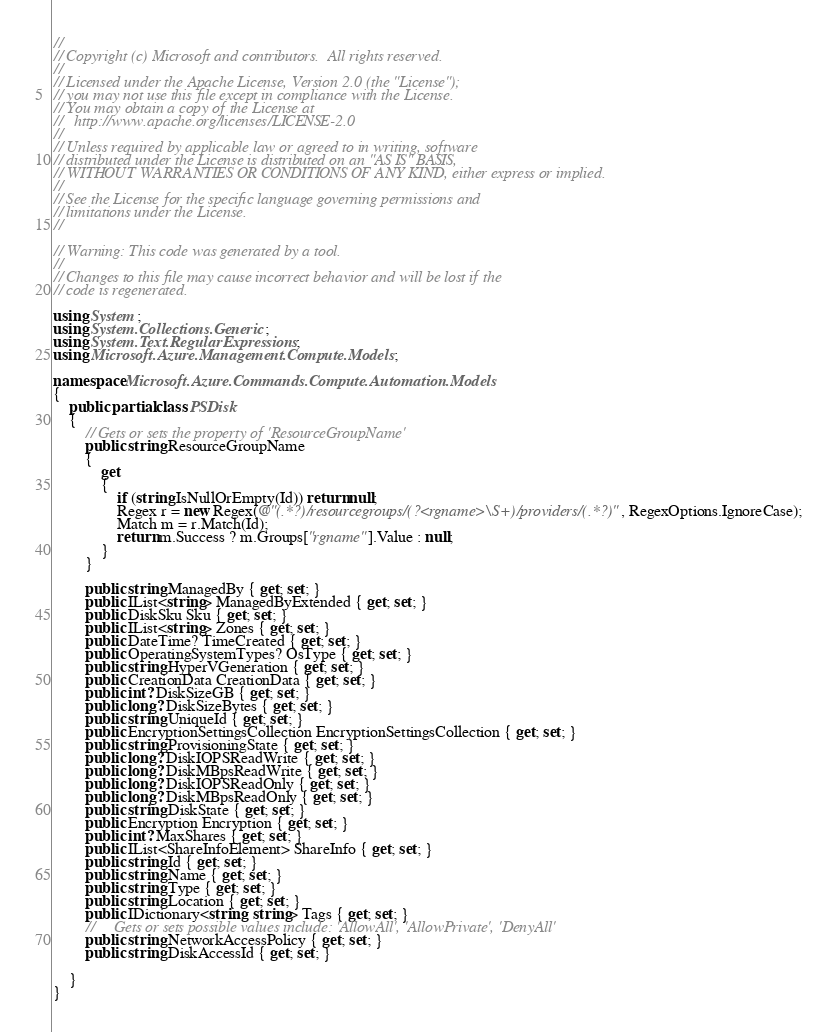<code> <loc_0><loc_0><loc_500><loc_500><_C#_>//
// Copyright (c) Microsoft and contributors.  All rights reserved.
//
// Licensed under the Apache License, Version 2.0 (the "License");
// you may not use this file except in compliance with the License.
// You may obtain a copy of the License at
//   http://www.apache.org/licenses/LICENSE-2.0
//
// Unless required by applicable law or agreed to in writing, software
// distributed under the License is distributed on an "AS IS" BASIS,
// WITHOUT WARRANTIES OR CONDITIONS OF ANY KIND, either express or implied.
//
// See the License for the specific language governing permissions and
// limitations under the License.
//

// Warning: This code was generated by a tool.
//
// Changes to this file may cause incorrect behavior and will be lost if the
// code is regenerated.

using System;
using System.Collections.Generic;
using System.Text.RegularExpressions;
using Microsoft.Azure.Management.Compute.Models;

namespace Microsoft.Azure.Commands.Compute.Automation.Models
{
    public partial class PSDisk
    {
        // Gets or sets the property of 'ResourceGroupName'
        public string ResourceGroupName
        {
            get
            {
                if (string.IsNullOrEmpty(Id)) return null;
                Regex r = new Regex(@"(.*?)/resourcegroups/(?<rgname>\S+)/providers/(.*?)", RegexOptions.IgnoreCase);
                Match m = r.Match(Id);
                return m.Success ? m.Groups["rgname"].Value : null;
            }
        }

        public string ManagedBy { get; set; }
        public IList<string> ManagedByExtended { get; set; }
        public DiskSku Sku { get; set; }
        public IList<string> Zones { get; set; }
        public DateTime? TimeCreated { get; set; }
        public OperatingSystemTypes? OsType { get; set; }
        public string HyperVGeneration { get; set; }
        public CreationData CreationData { get; set; }
        public int? DiskSizeGB { get; set; }
        public long? DiskSizeBytes { get; set; }
        public string UniqueId { get; set; }
        public EncryptionSettingsCollection EncryptionSettingsCollection { get; set; }
        public string ProvisioningState { get; set; }
        public long? DiskIOPSReadWrite { get; set; }
        public long? DiskMBpsReadWrite { get; set; }
        public long? DiskIOPSReadOnly { get; set; }
        public long? DiskMBpsReadOnly { get; set; }
        public string DiskState { get; set; }
        public Encryption Encryption { get; set; }
        public int? MaxShares { get; set; }
        public IList<ShareInfoElement> ShareInfo { get; set; }
        public string Id { get; set; }
        public string Name { get; set; }
        public string Type { get; set; }
        public string Location { get; set; }
        public IDictionary<string, string> Tags { get; set; }
        //     Gets or sets possible values include: 'AllowAll', 'AllowPrivate', 'DenyAll'
        public string NetworkAccessPolicy { get; set; }
        public string DiskAccessId { get; set; }

    }
}
</code> 